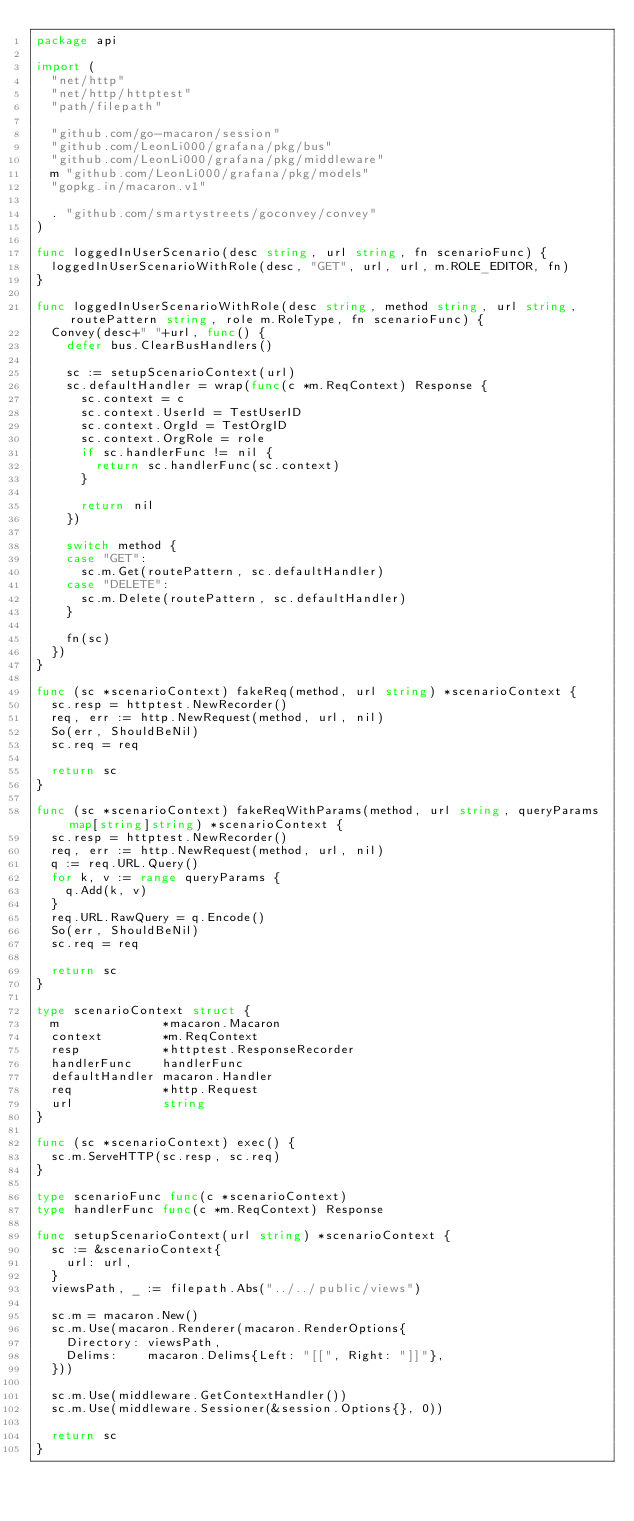Convert code to text. <code><loc_0><loc_0><loc_500><loc_500><_Go_>package api

import (
	"net/http"
	"net/http/httptest"
	"path/filepath"

	"github.com/go-macaron/session"
	"github.com/LeonLi000/grafana/pkg/bus"
	"github.com/LeonLi000/grafana/pkg/middleware"
	m "github.com/LeonLi000/grafana/pkg/models"
	"gopkg.in/macaron.v1"

	. "github.com/smartystreets/goconvey/convey"
)

func loggedInUserScenario(desc string, url string, fn scenarioFunc) {
	loggedInUserScenarioWithRole(desc, "GET", url, url, m.ROLE_EDITOR, fn)
}

func loggedInUserScenarioWithRole(desc string, method string, url string, routePattern string, role m.RoleType, fn scenarioFunc) {
	Convey(desc+" "+url, func() {
		defer bus.ClearBusHandlers()

		sc := setupScenarioContext(url)
		sc.defaultHandler = wrap(func(c *m.ReqContext) Response {
			sc.context = c
			sc.context.UserId = TestUserID
			sc.context.OrgId = TestOrgID
			sc.context.OrgRole = role
			if sc.handlerFunc != nil {
				return sc.handlerFunc(sc.context)
			}

			return nil
		})

		switch method {
		case "GET":
			sc.m.Get(routePattern, sc.defaultHandler)
		case "DELETE":
			sc.m.Delete(routePattern, sc.defaultHandler)
		}

		fn(sc)
	})
}

func (sc *scenarioContext) fakeReq(method, url string) *scenarioContext {
	sc.resp = httptest.NewRecorder()
	req, err := http.NewRequest(method, url, nil)
	So(err, ShouldBeNil)
	sc.req = req

	return sc
}

func (sc *scenarioContext) fakeReqWithParams(method, url string, queryParams map[string]string) *scenarioContext {
	sc.resp = httptest.NewRecorder()
	req, err := http.NewRequest(method, url, nil)
	q := req.URL.Query()
	for k, v := range queryParams {
		q.Add(k, v)
	}
	req.URL.RawQuery = q.Encode()
	So(err, ShouldBeNil)
	sc.req = req

	return sc
}

type scenarioContext struct {
	m              *macaron.Macaron
	context        *m.ReqContext
	resp           *httptest.ResponseRecorder
	handlerFunc    handlerFunc
	defaultHandler macaron.Handler
	req            *http.Request
	url            string
}

func (sc *scenarioContext) exec() {
	sc.m.ServeHTTP(sc.resp, sc.req)
}

type scenarioFunc func(c *scenarioContext)
type handlerFunc func(c *m.ReqContext) Response

func setupScenarioContext(url string) *scenarioContext {
	sc := &scenarioContext{
		url: url,
	}
	viewsPath, _ := filepath.Abs("../../public/views")

	sc.m = macaron.New()
	sc.m.Use(macaron.Renderer(macaron.RenderOptions{
		Directory: viewsPath,
		Delims:    macaron.Delims{Left: "[[", Right: "]]"},
	}))

	sc.m.Use(middleware.GetContextHandler())
	sc.m.Use(middleware.Sessioner(&session.Options{}, 0))

	return sc
}
</code> 